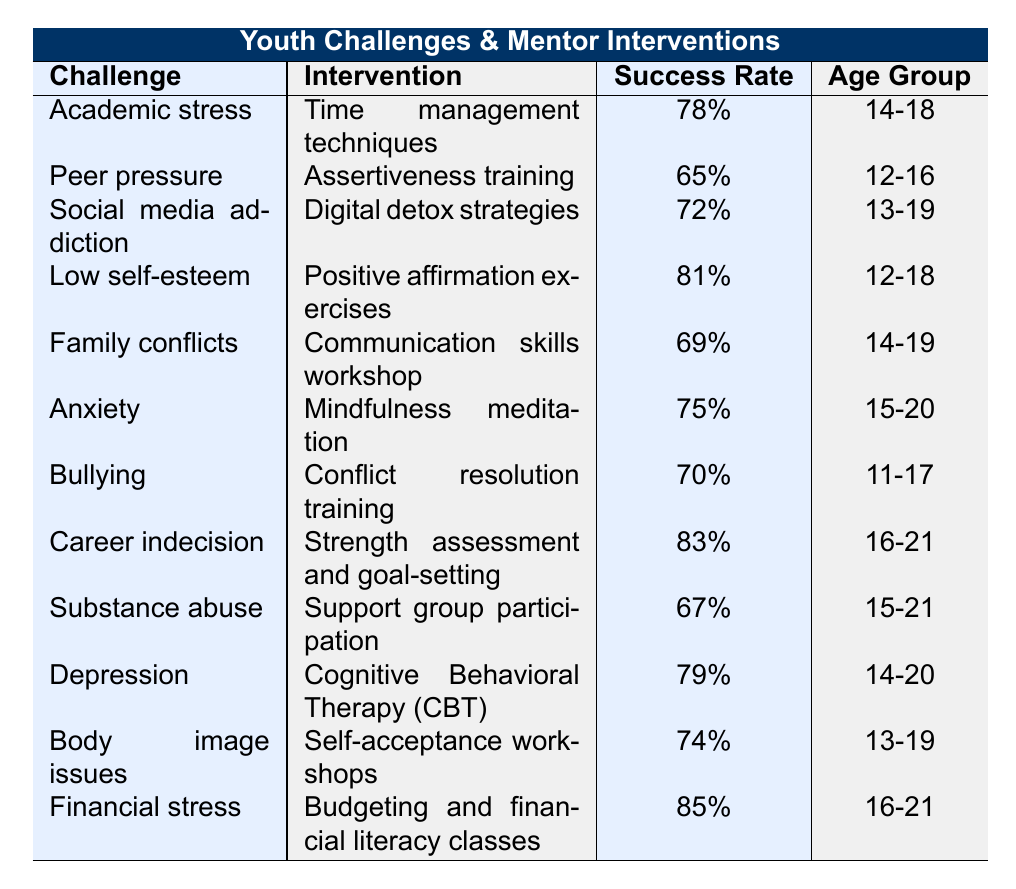What is the most effective intervention based on the success rate? The highest success rate is 85% for "Budgeting and financial literacy classes" related to "Financial stress."
Answer: 85% Which challenge has the lowest success rate? The challenge with the lowest success rate is "Peer pressure," which has a success rate of 65%.
Answer: 65% What age group is targeted for the "Cognitive Behavioral Therapy (CBT)" intervention? The age group for "Cognitive Behavioral Therapy (CBT)" is 14-20 years old.
Answer: 14-20 Is "Substance abuse" addressed by an intervention with a success rate lower than 70%? Yes, the intervention for "Substance abuse," which is "Support group participation," has a success rate of 67%.
Answer: Yes Which challenges are addressed for the age group "16-21"? The challenges addressed for this age group are "Career indecision" and "Financial stress."
Answer: Career indecision and Financial stress What is the average success rate of the interventions for challenges faced by the age group "15-21"? The success rates for this age group comprise 75% (Anxiety), 67% (Substance abuse), and 83% (Career indecision). To find the average, sum these rates (75 + 67 + 83 = 225) and divide by 3, giving an average of 225/3 = 75%.
Answer: 75% How many interventions have a success rate of 80% or higher? There are three interventions with a success rate of 80% or higher: "Positive affirmation exercises" (81%), "Career indecision" (83%), and "Budgeting and financial literacy classes" (85%).
Answer: 3 Which two challenges have success rates closest to each other? The challenges "Body image issues" (74%) and "Social media addiction" (72%) have the closest success rates, differing by only 2%.
Answer: 2% Is there an intervention that addresses both "Bullying" and "Low self-esteem"? No, there are no interventions listed that address both challenges simultaneously.
Answer: No What percentage of the interventions are aimed at the age group "14-19"? There are four interventions aimed at "14-19": "Academic stress," "Family conflicts," "Depression," and "Social media addiction." This makes 4 out of 12 interventions, or approximately 33.33%.
Answer: 33.33% 